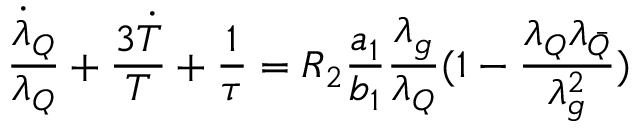<formula> <loc_0><loc_0><loc_500><loc_500>\frac { { \dot { \lambda } } _ { Q } } { \lambda _ { Q } } + \frac { { 3 \dot { T } } } { T } + \frac { 1 } { \tau } = R _ { 2 } \frac { a _ { 1 } } { b _ { 1 } } \frac { \lambda _ { g } } { \lambda _ { Q } } ( 1 - \frac { \lambda _ { Q } \lambda _ { \bar { Q } } } { \lambda _ { g } ^ { 2 } } )</formula> 